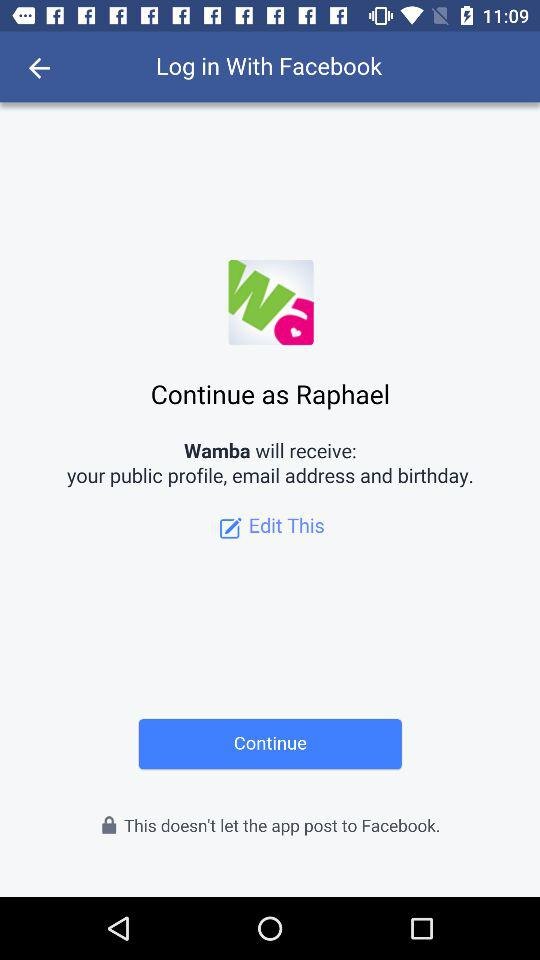Who developed "Wamba"?
When the provided information is insufficient, respond with <no answer>. <no answer> 